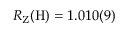Convert formula to latex. <formula><loc_0><loc_0><loc_500><loc_500>R _ { Z } ( H ) = 1 . 0 1 0 ( 9 )</formula> 